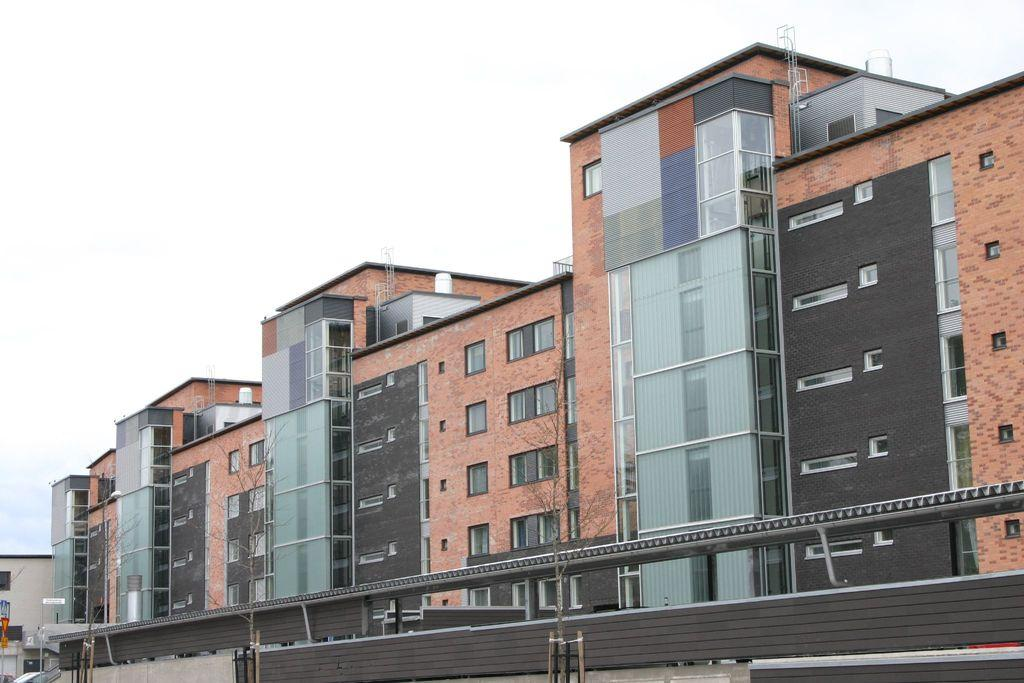What type of structures can be seen in the image? There are buildings in the image. What other natural elements are present in the image? There are trees in the image. What part of the buildings can be seen in the image? There are windows in the image. What architectural feature is visible in the image? There is a wall in the image. What can be seen in the background of the image? The sky is visible in the background of the image. What atmospheric conditions can be observed in the sky? Clouds are present in the sky. What type of bait is being used to catch fish in the image? There is no fishing or bait present in the image; it features buildings, trees, windows, a wall, and a sky with clouds. What type of badge is being worn by the person in the image? There is no person or badge present in the image. 